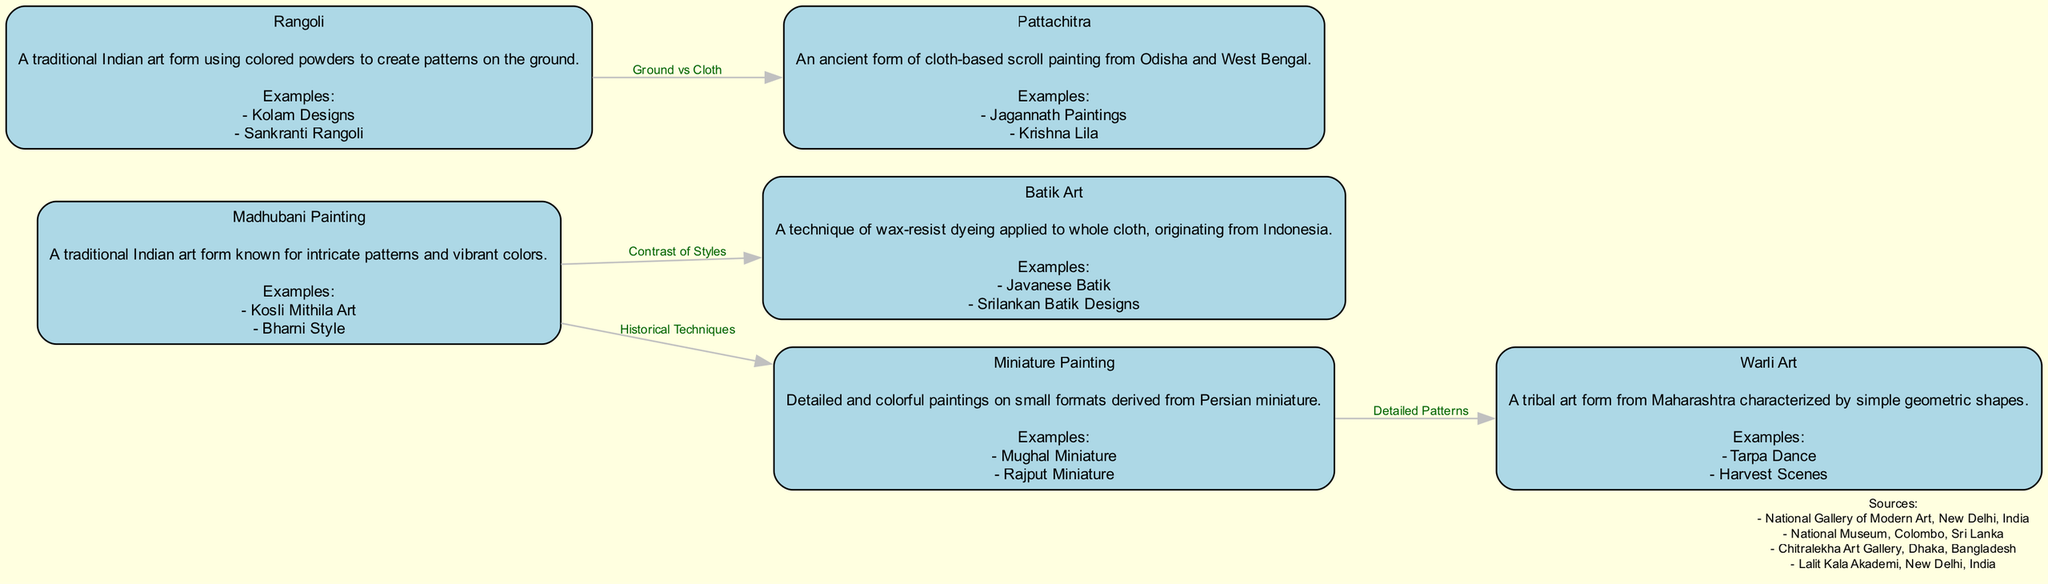What is the title of the diagram? The title is explicitly provided at the top of the diagram, which summarizes the content covered. In this case, the title is "Various Art Techniques Popular in South Asian Studios."
Answer: Various Art Techniques Popular in South Asian Studios How many nodes are there in the diagram? The diagram contains six distinct nodes, each representing a different art technique. By counting the entries in the "nodes" list, we can determine the total.
Answer: 6 What is the description of Madhubani Painting? Each node in the diagram includes a specific description. For Madhubani Painting, the provided description is "A traditional Indian art form known for intricate patterns and vibrant colors."
Answer: A traditional Indian art form known for intricate patterns and vibrant colors Which two art techniques are compared through a "Contrast of Styles" edge? The edges in the diagram indicate relationships between different art techniques. In this case, the edge labeled "Contrast of Styles" connects Madhubani Painting and Batik Art, showing a relationship of comparison.
Answer: Madhubani Painting and Batik Art Which art technique is characterized by simple geometric shapes? The description for Warli Art specifies that it is characterized by simple geometric shapes; therefore, this is the answer to the question regarding the specific art technique.
Answer: Warli Art What are the examples of Pattachitra? Each node in the diagram includes examples corresponding to each art technique. For Pattachitra, the examples listed are "Jagannath Paintings" and "Krishna Lila," so the answer should mention both examples succinctly.
Answer: Jagannath Paintings, Krishna Lila What relationship does "Ground vs Cloth" represent? The edge labeled "Ground vs Cloth" illustrates a relationship between Rangoli, which is created on the ground, and Pattachitra, which is a cloth-based art form. This emphasizes the medium differences between these two techniques.
Answer: Rangoli and Pattachitra How many edges emerge from Madhubani Painting? By examining the connections for Madhubani Painting, we can identify that it has connections to three different edges: to Batik Art (Contrast of Styles), to Miniature Painting (Historical Techniques), and to Rangoli (Ground vs Cloth). Therefore, the count of edges will give us the final answer.
Answer: 3 